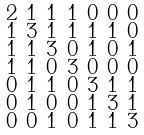Convert formula to latex. <formula><loc_0><loc_0><loc_500><loc_500>\begin{smallmatrix} 2 & 1 & 1 & 1 & 0 & 0 & 0 \\ 1 & 3 & 1 & 1 & 1 & 1 & 0 \\ 1 & 1 & 3 & 0 & 1 & 0 & 1 \\ 1 & 1 & 0 & 3 & 0 & 0 & 0 \\ 0 & 1 & 1 & 0 & 3 & 1 & 1 \\ 0 & 1 & 0 & 0 & 1 & 3 & 1 \\ 0 & 0 & 1 & 0 & 1 & 1 & 3 \end{smallmatrix}</formula> 